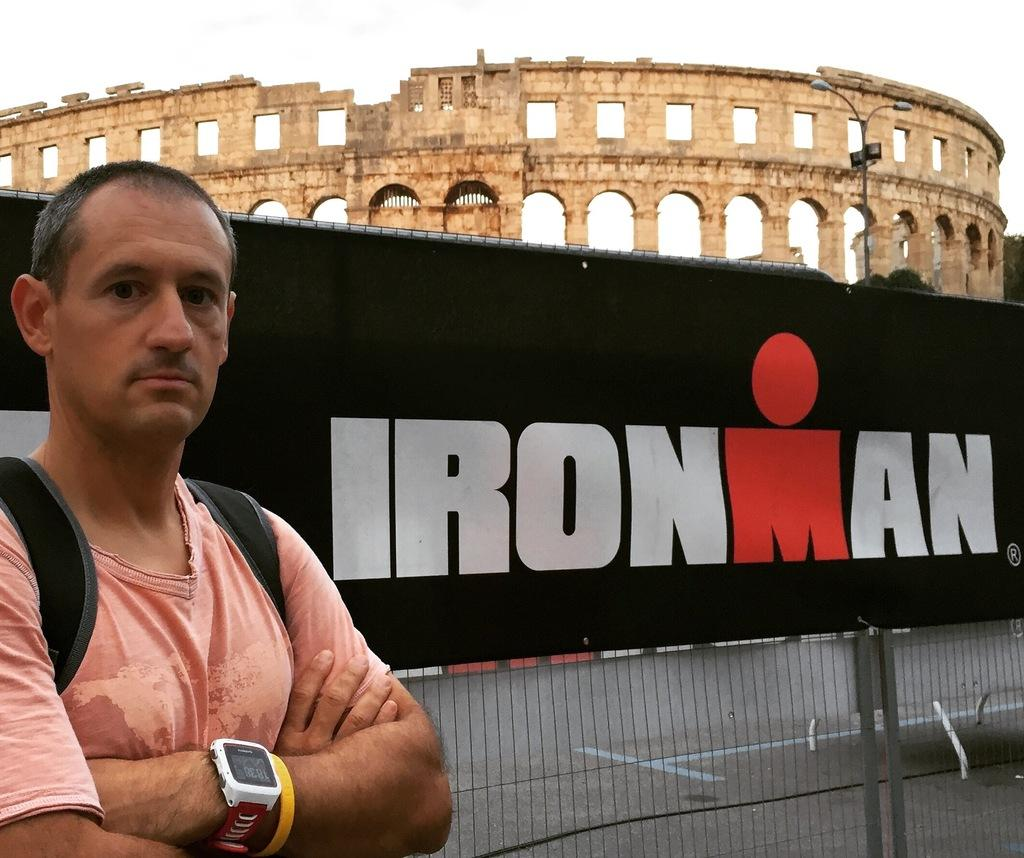<image>
Summarize the visual content of the image. A man in a peach shirt posing by an Ironman banner in front of a ruin. 